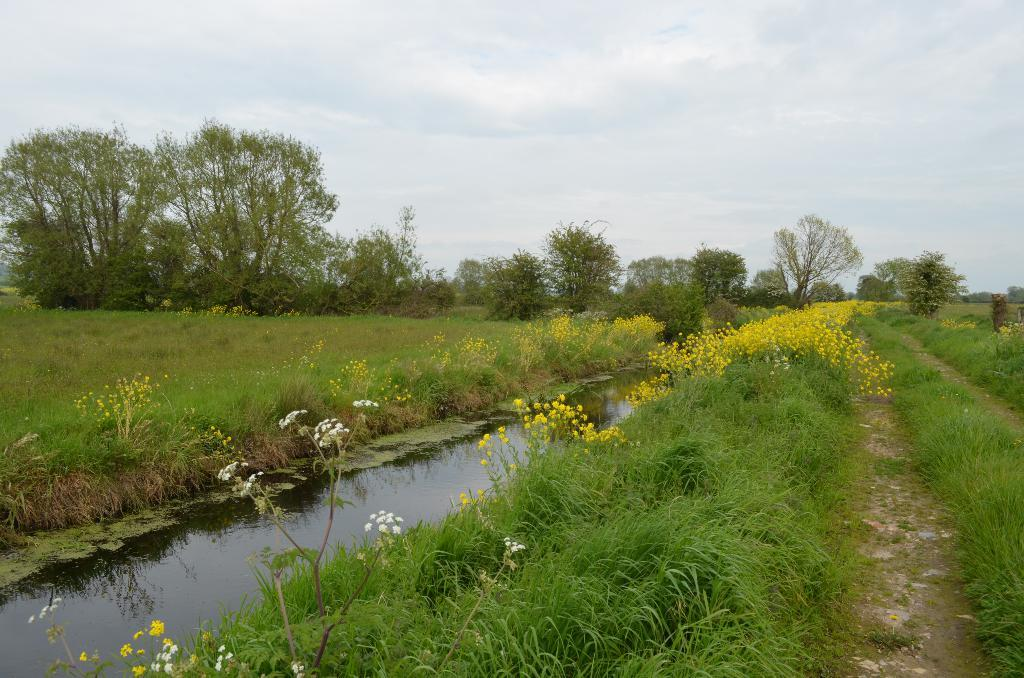What type of landscape is depicted in the image? There is a grassland in the image. What feature can be seen in the middle of the grassland? There is a canal in the middle of the image. What can be seen in the distance in the image? There are trees in the background of the image. What is visible above the grassland and trees in the image? The sky is visible in the background of the image. Where is the alley located in the image? There is no alley present in the image; it features a grassland, a canal, trees, and the sky. What type of bird can be seen perched on the trees in the image? There are no birds visible in the image, including robins. 